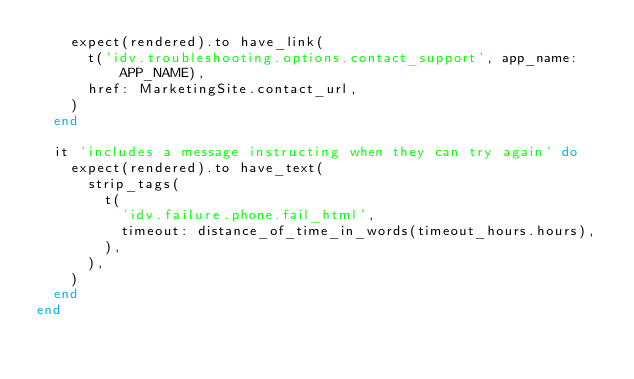Convert code to text. <code><loc_0><loc_0><loc_500><loc_500><_Ruby_>    expect(rendered).to have_link(
      t('idv.troubleshooting.options.contact_support', app_name: APP_NAME),
      href: MarketingSite.contact_url,
    )
  end

  it 'includes a message instructing when they can try again' do
    expect(rendered).to have_text(
      strip_tags(
        t(
          'idv.failure.phone.fail_html',
          timeout: distance_of_time_in_words(timeout_hours.hours),
        ),
      ),
    )
  end
end
</code> 